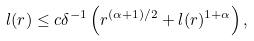<formula> <loc_0><loc_0><loc_500><loc_500>l ( r ) \leq c \delta ^ { - 1 } \left ( r ^ { ( \alpha + 1 ) / 2 } + l ( r ) ^ { 1 + \alpha } \right ) ,</formula> 